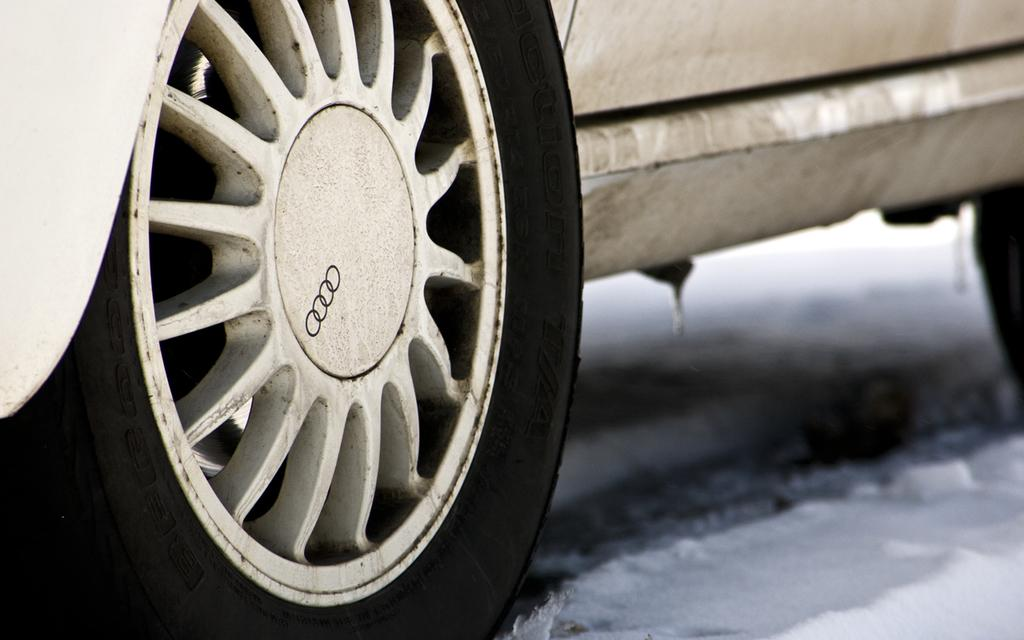What is the main subject of the picture? The main subject of the picture is a vehicle. What feature of the vehicle is mentioned in the facts? The vehicle has a wheel. Is there any additional detail about the wheel? Yes, there is a logo on the wheel. How does the vehicle perform in a test in the image? There is no information about a test in the image, so we cannot answer this question. 